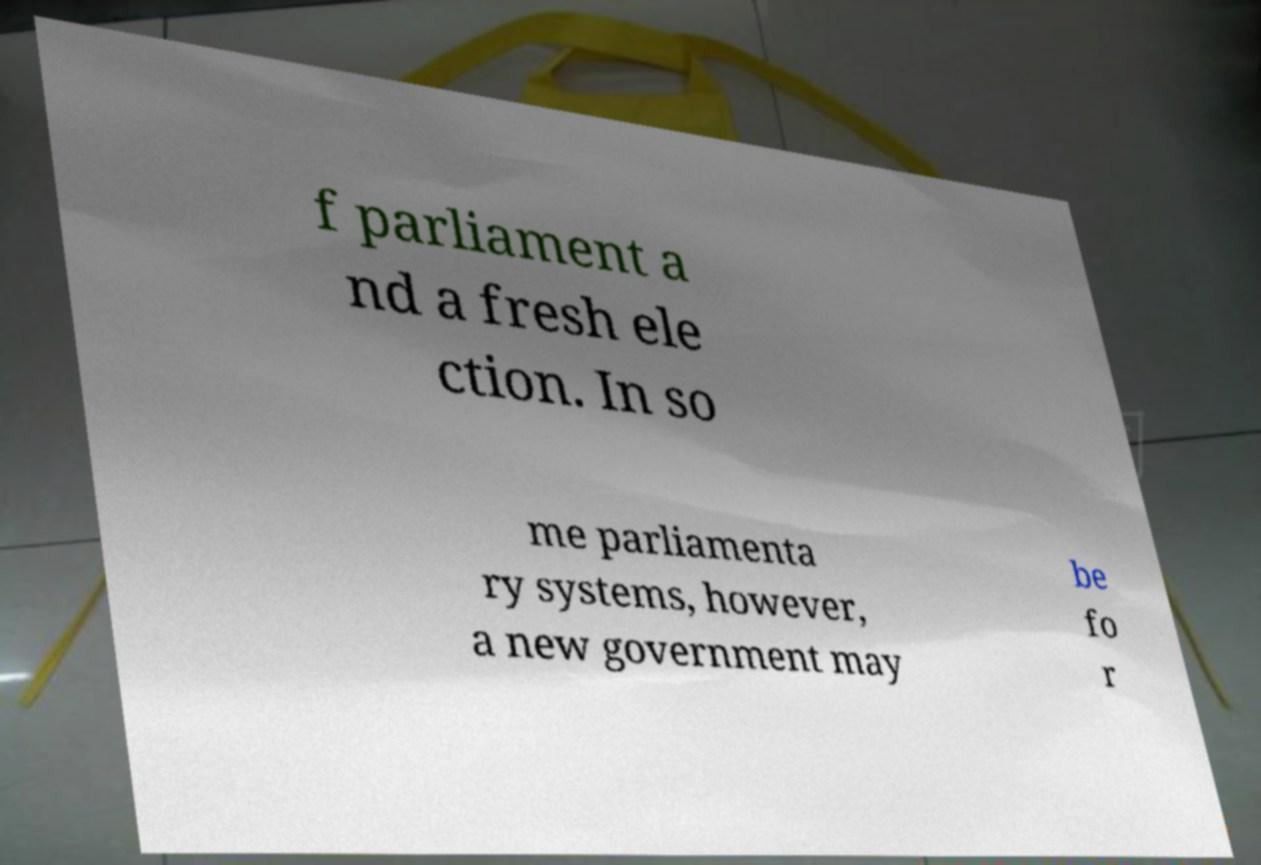Could you extract and type out the text from this image? f parliament a nd a fresh ele ction. In so me parliamenta ry systems, however, a new government may be fo r 